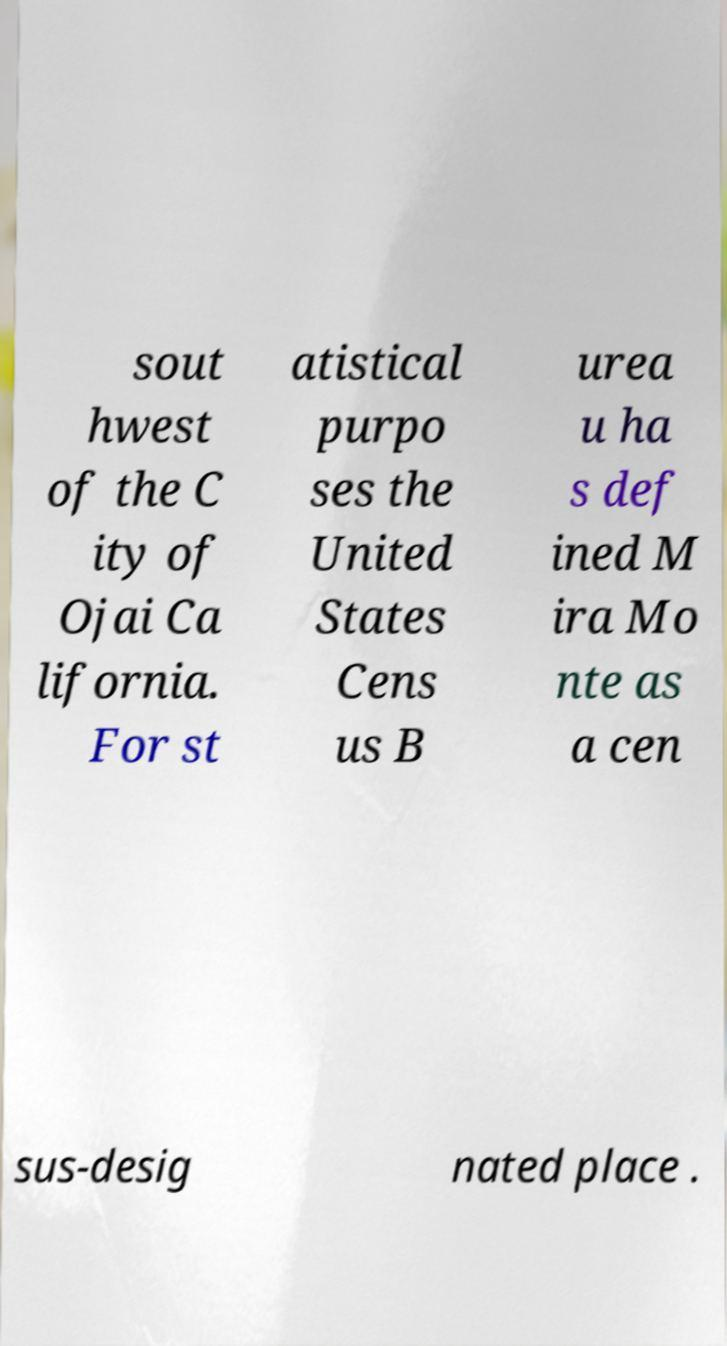For documentation purposes, I need the text within this image transcribed. Could you provide that? sout hwest of the C ity of Ojai Ca lifornia. For st atistical purpo ses the United States Cens us B urea u ha s def ined M ira Mo nte as a cen sus-desig nated place . 